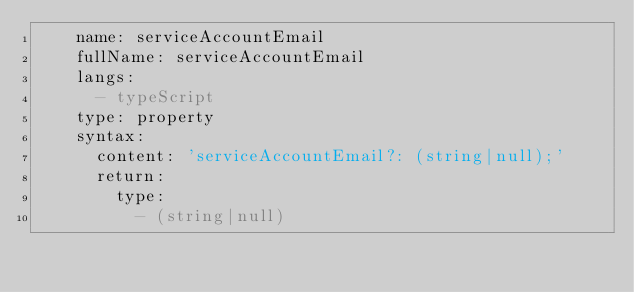<code> <loc_0><loc_0><loc_500><loc_500><_YAML_>    name: serviceAccountEmail
    fullName: serviceAccountEmail
    langs:
      - typeScript
    type: property
    syntax:
      content: 'serviceAccountEmail?: (string|null);'
      return:
        type:
          - (string|null)
</code> 